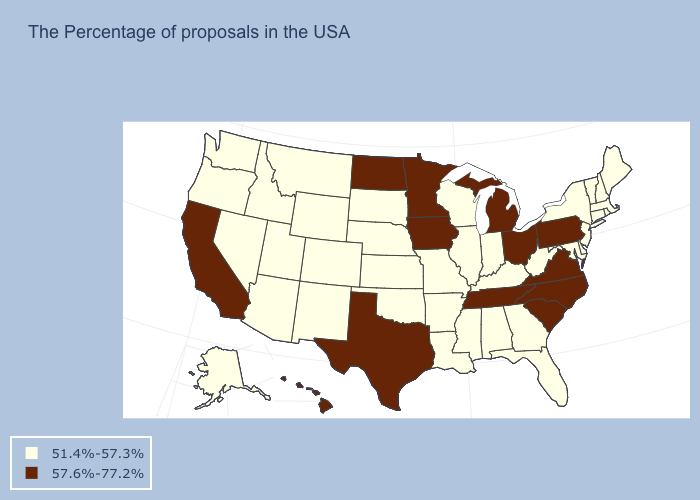Name the states that have a value in the range 57.6%-77.2%?
Be succinct. Pennsylvania, Virginia, North Carolina, South Carolina, Ohio, Michigan, Tennessee, Minnesota, Iowa, Texas, North Dakota, California, Hawaii. Is the legend a continuous bar?
Quick response, please. No. Which states have the highest value in the USA?
Answer briefly. Pennsylvania, Virginia, North Carolina, South Carolina, Ohio, Michigan, Tennessee, Minnesota, Iowa, Texas, North Dakota, California, Hawaii. Does the first symbol in the legend represent the smallest category?
Write a very short answer. Yes. Which states have the lowest value in the USA?
Quick response, please. Maine, Massachusetts, Rhode Island, New Hampshire, Vermont, Connecticut, New York, New Jersey, Delaware, Maryland, West Virginia, Florida, Georgia, Kentucky, Indiana, Alabama, Wisconsin, Illinois, Mississippi, Louisiana, Missouri, Arkansas, Kansas, Nebraska, Oklahoma, South Dakota, Wyoming, Colorado, New Mexico, Utah, Montana, Arizona, Idaho, Nevada, Washington, Oregon, Alaska. Name the states that have a value in the range 57.6%-77.2%?
Answer briefly. Pennsylvania, Virginia, North Carolina, South Carolina, Ohio, Michigan, Tennessee, Minnesota, Iowa, Texas, North Dakota, California, Hawaii. Name the states that have a value in the range 51.4%-57.3%?
Write a very short answer. Maine, Massachusetts, Rhode Island, New Hampshire, Vermont, Connecticut, New York, New Jersey, Delaware, Maryland, West Virginia, Florida, Georgia, Kentucky, Indiana, Alabama, Wisconsin, Illinois, Mississippi, Louisiana, Missouri, Arkansas, Kansas, Nebraska, Oklahoma, South Dakota, Wyoming, Colorado, New Mexico, Utah, Montana, Arizona, Idaho, Nevada, Washington, Oregon, Alaska. What is the value of Florida?
Concise answer only. 51.4%-57.3%. Among the states that border North Carolina , does Virginia have the highest value?
Short answer required. Yes. What is the value of Vermont?
Quick response, please. 51.4%-57.3%. What is the value of Vermont?
Give a very brief answer. 51.4%-57.3%. Among the states that border Georgia , does Tennessee have the highest value?
Write a very short answer. Yes. Does the map have missing data?
Concise answer only. No. What is the value of Virginia?
Keep it brief. 57.6%-77.2%. How many symbols are there in the legend?
Quick response, please. 2. 